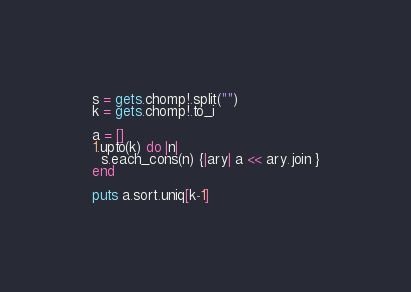<code> <loc_0><loc_0><loc_500><loc_500><_Ruby_>s = gets.chomp!.split("")
k = gets.chomp!.to_i

a = []
1.upto(k) do |n|
  s.each_cons(n) {|ary| a << ary.join }
end

puts a.sort.uniq[k-1]</code> 